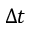<formula> <loc_0><loc_0><loc_500><loc_500>\Delta t</formula> 